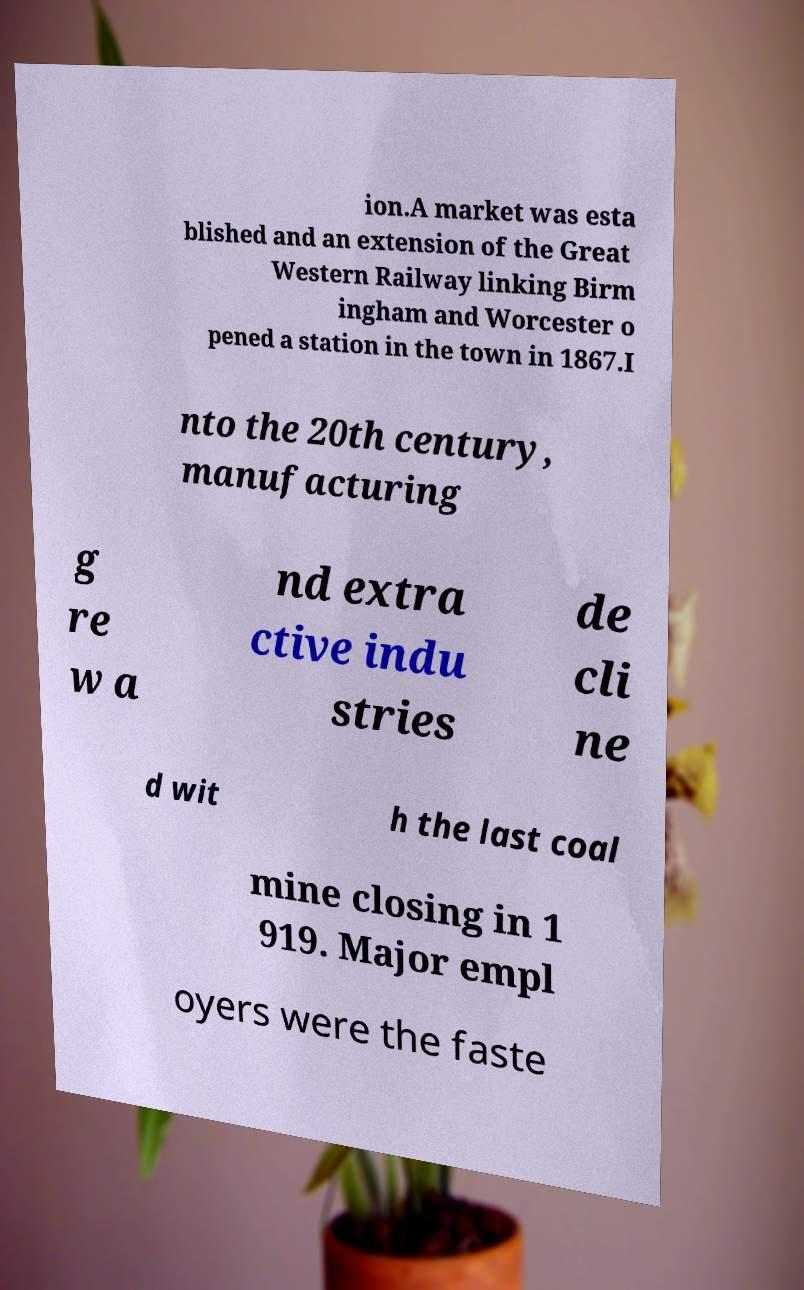Can you read and provide the text displayed in the image?This photo seems to have some interesting text. Can you extract and type it out for me? ion.A market was esta blished and an extension of the Great Western Railway linking Birm ingham and Worcester o pened a station in the town in 1867.I nto the 20th century, manufacturing g re w a nd extra ctive indu stries de cli ne d wit h the last coal mine closing in 1 919. Major empl oyers were the faste 